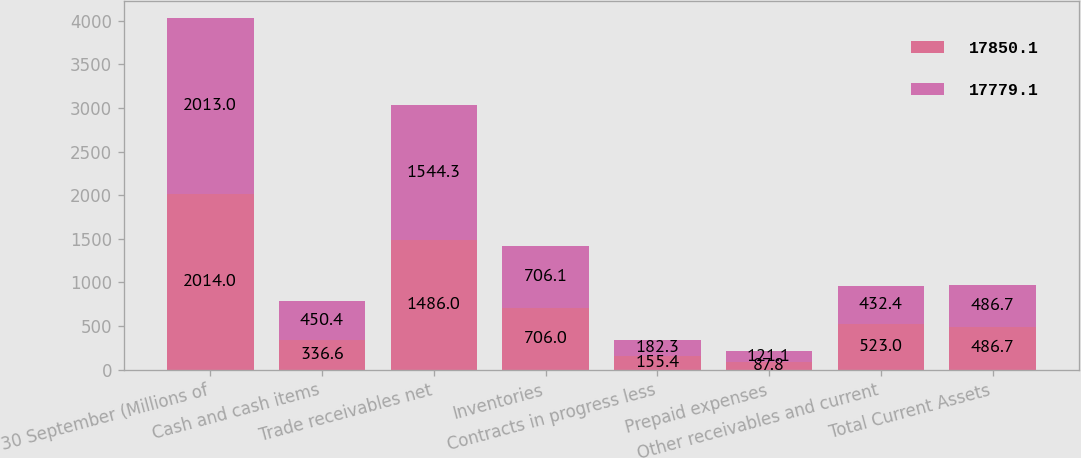Convert chart. <chart><loc_0><loc_0><loc_500><loc_500><stacked_bar_chart><ecel><fcel>30 September (Millions of<fcel>Cash and cash items<fcel>Trade receivables net<fcel>Inventories<fcel>Contracts in progress less<fcel>Prepaid expenses<fcel>Other receivables and current<fcel>Total Current Assets<nl><fcel>17850.1<fcel>2014<fcel>336.6<fcel>1486<fcel>706<fcel>155.4<fcel>87.8<fcel>523<fcel>486.7<nl><fcel>17779.1<fcel>2013<fcel>450.4<fcel>1544.3<fcel>706.1<fcel>182.3<fcel>121.1<fcel>432.4<fcel>486.7<nl></chart> 